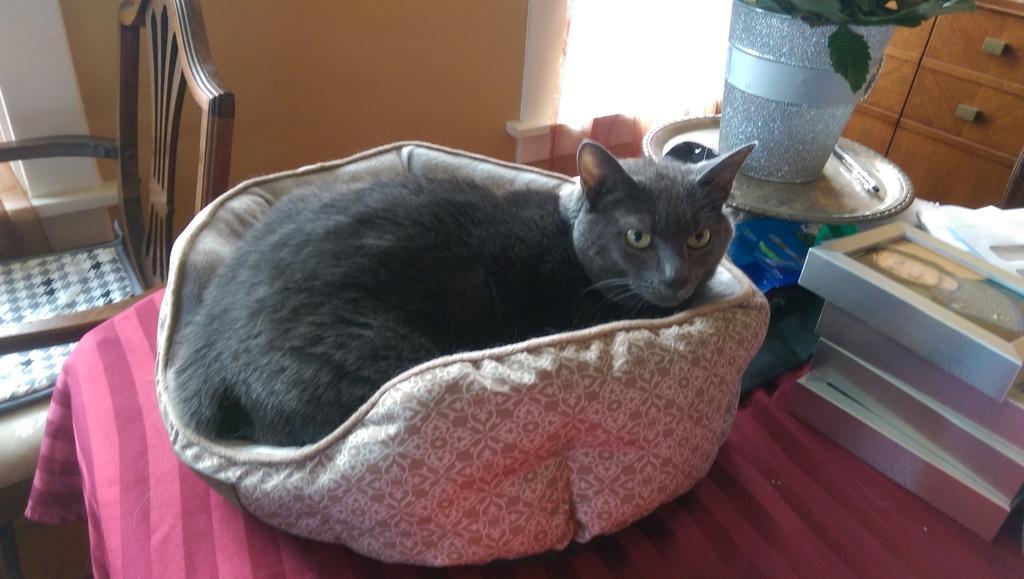Can you describe this image briefly? We can see cat in pet bed, frames, leaves in container, plate, pen and few objects on the table, beside this table we can see chair. In the background we can see cupboards and wall. 